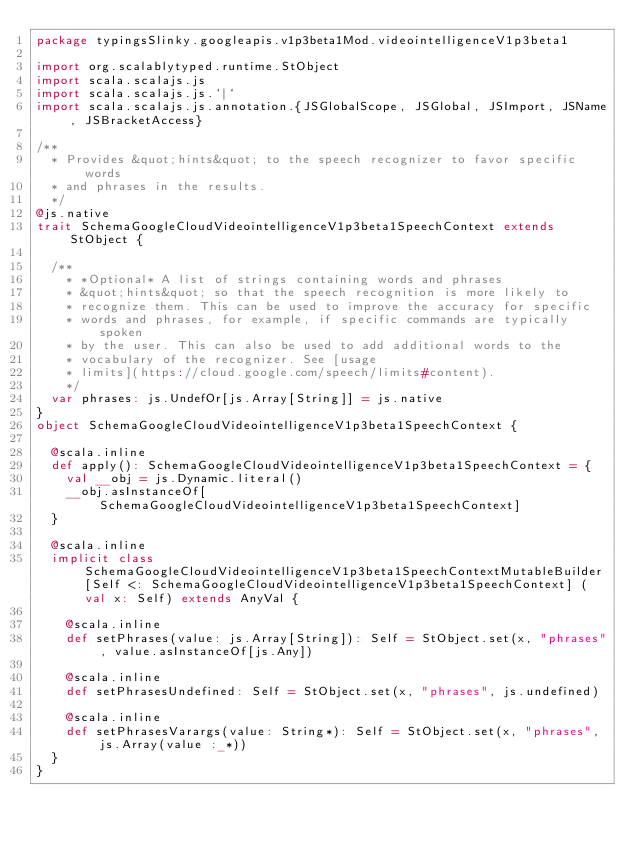Convert code to text. <code><loc_0><loc_0><loc_500><loc_500><_Scala_>package typingsSlinky.googleapis.v1p3beta1Mod.videointelligenceV1p3beta1

import org.scalablytyped.runtime.StObject
import scala.scalajs.js
import scala.scalajs.js.`|`
import scala.scalajs.js.annotation.{JSGlobalScope, JSGlobal, JSImport, JSName, JSBracketAccess}

/**
  * Provides &quot;hints&quot; to the speech recognizer to favor specific words
  * and phrases in the results.
  */
@js.native
trait SchemaGoogleCloudVideointelligenceV1p3beta1SpeechContext extends StObject {
  
  /**
    * *Optional* A list of strings containing words and phrases
    * &quot;hints&quot; so that the speech recognition is more likely to
    * recognize them. This can be used to improve the accuracy for specific
    * words and phrases, for example, if specific commands are typically spoken
    * by the user. This can also be used to add additional words to the
    * vocabulary of the recognizer. See [usage
    * limits](https://cloud.google.com/speech/limits#content).
    */
  var phrases: js.UndefOr[js.Array[String]] = js.native
}
object SchemaGoogleCloudVideointelligenceV1p3beta1SpeechContext {
  
  @scala.inline
  def apply(): SchemaGoogleCloudVideointelligenceV1p3beta1SpeechContext = {
    val __obj = js.Dynamic.literal()
    __obj.asInstanceOf[SchemaGoogleCloudVideointelligenceV1p3beta1SpeechContext]
  }
  
  @scala.inline
  implicit class SchemaGoogleCloudVideointelligenceV1p3beta1SpeechContextMutableBuilder[Self <: SchemaGoogleCloudVideointelligenceV1p3beta1SpeechContext] (val x: Self) extends AnyVal {
    
    @scala.inline
    def setPhrases(value: js.Array[String]): Self = StObject.set(x, "phrases", value.asInstanceOf[js.Any])
    
    @scala.inline
    def setPhrasesUndefined: Self = StObject.set(x, "phrases", js.undefined)
    
    @scala.inline
    def setPhrasesVarargs(value: String*): Self = StObject.set(x, "phrases", js.Array(value :_*))
  }
}
</code> 